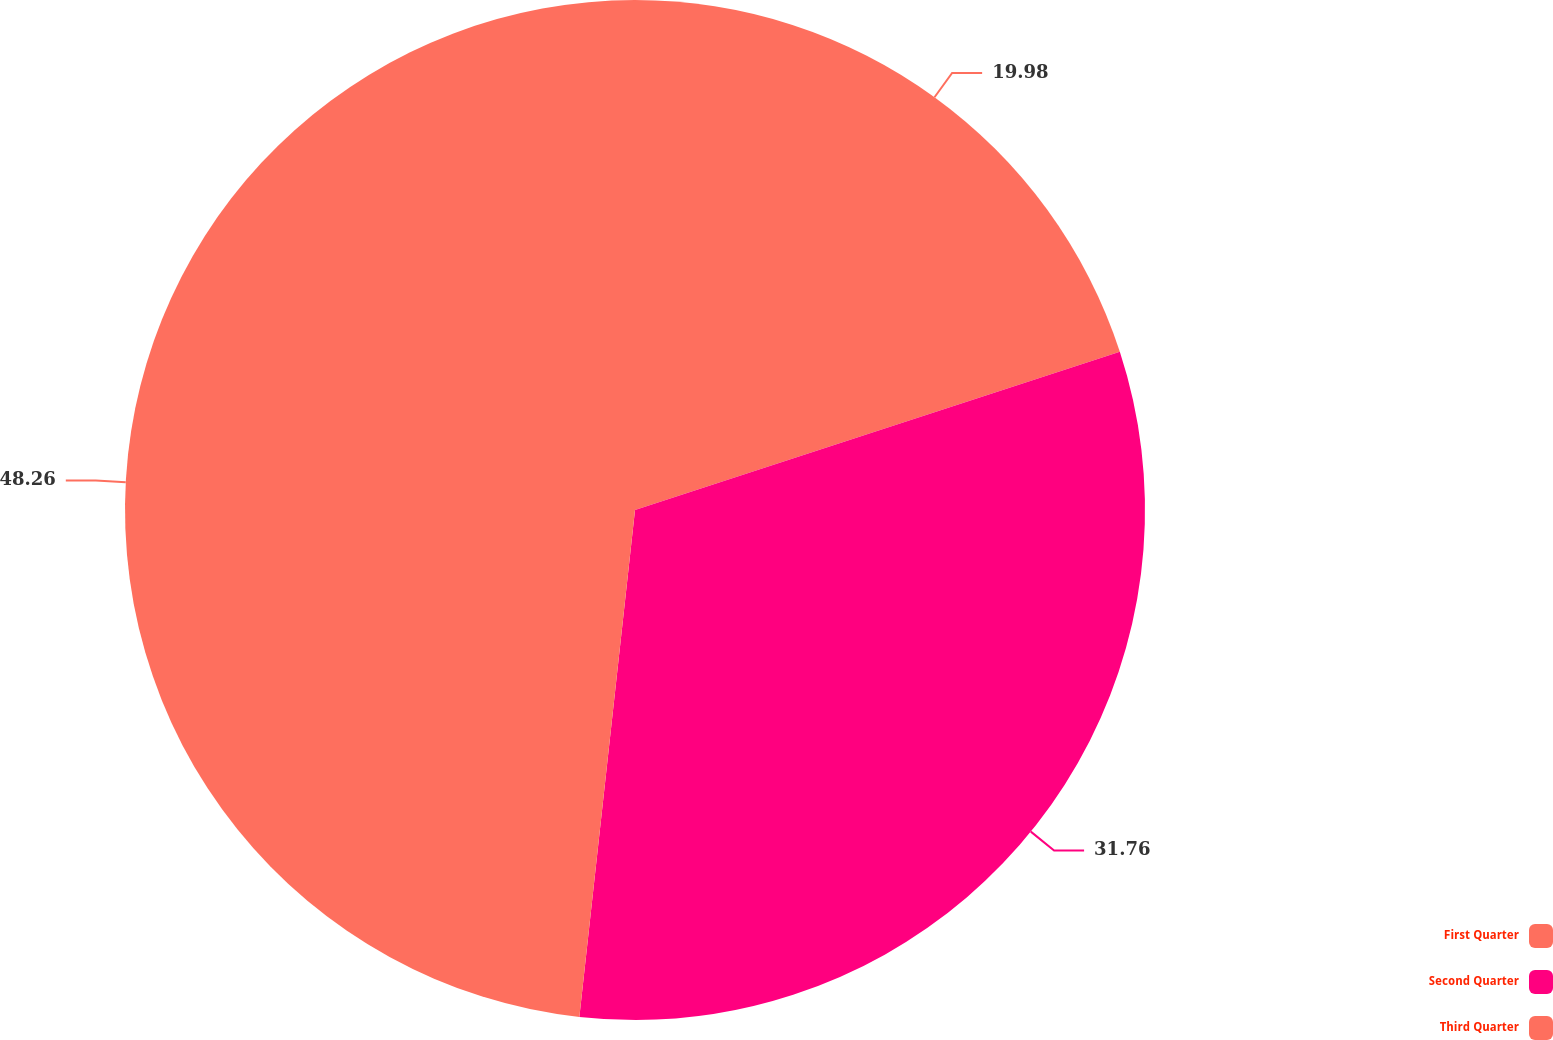Convert chart. <chart><loc_0><loc_0><loc_500><loc_500><pie_chart><fcel>First Quarter<fcel>Second Quarter<fcel>Third Quarter<nl><fcel>19.98%<fcel>31.76%<fcel>48.26%<nl></chart> 